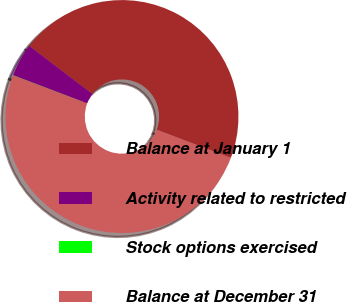Convert chart to OTSL. <chart><loc_0><loc_0><loc_500><loc_500><pie_chart><fcel>Balance at January 1<fcel>Activity related to restricted<fcel>Stock options exercised<fcel>Balance at December 31<nl><fcel>45.41%<fcel>4.59%<fcel>0.03%<fcel>49.97%<nl></chart> 